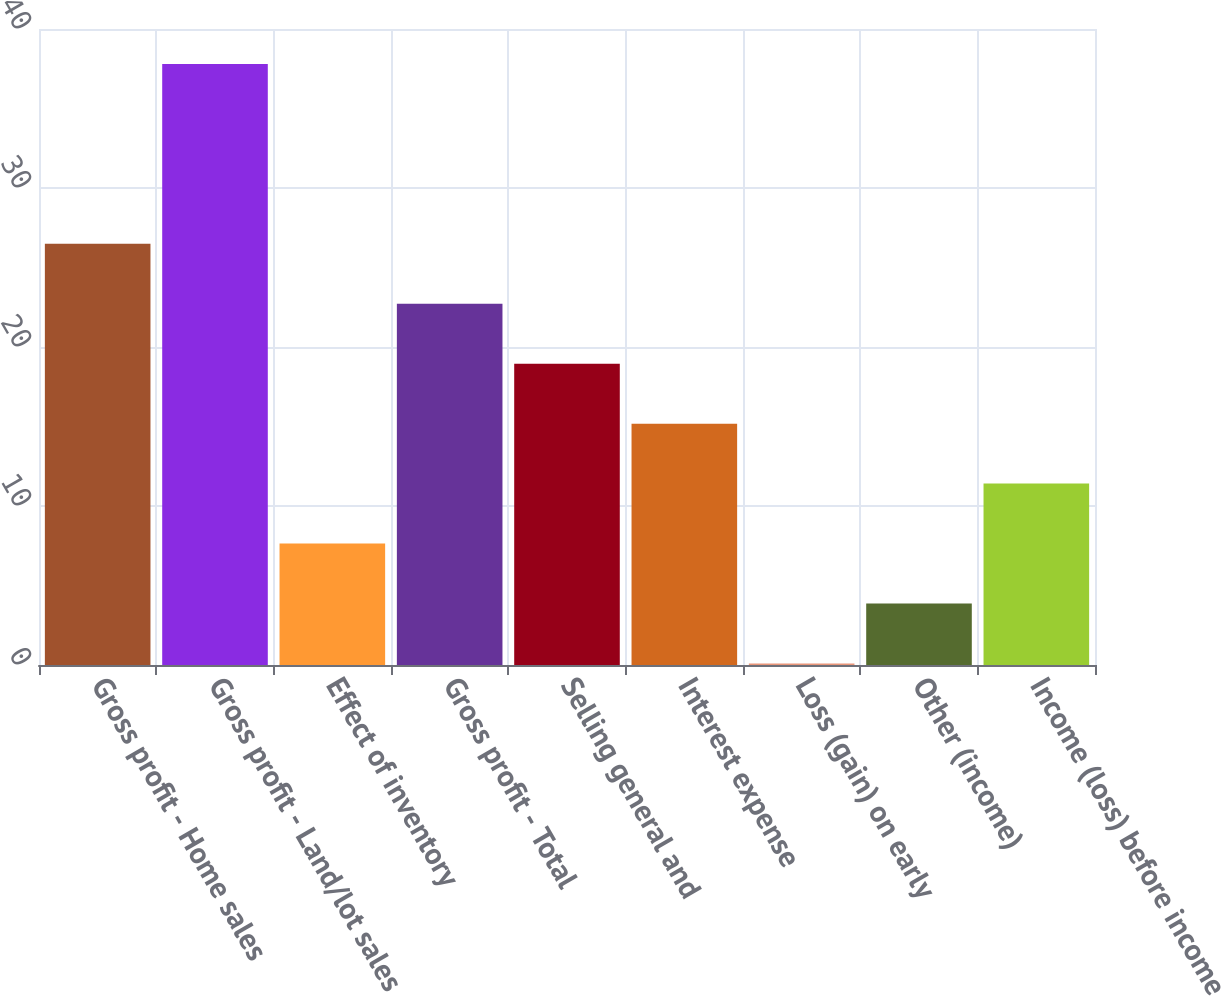Convert chart to OTSL. <chart><loc_0><loc_0><loc_500><loc_500><bar_chart><fcel>Gross profit - Home sales<fcel>Gross profit - Land/lot sales<fcel>Effect of inventory<fcel>Gross profit - Total<fcel>Selling general and<fcel>Interest expense<fcel>Loss (gain) on early<fcel>Other (income)<fcel>Income (loss) before income<nl><fcel>26.49<fcel>37.8<fcel>7.64<fcel>22.72<fcel>18.95<fcel>15.18<fcel>0.1<fcel>3.87<fcel>11.41<nl></chart> 